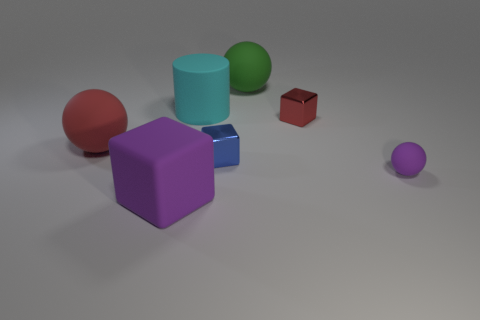Add 2 cyan matte cylinders. How many objects exist? 9 Subtract all big things. Subtract all red matte balls. How many objects are left? 2 Add 2 purple rubber things. How many purple rubber things are left? 4 Add 4 cyan rubber objects. How many cyan rubber objects exist? 5 Subtract 1 green spheres. How many objects are left? 6 Subtract all cylinders. How many objects are left? 6 